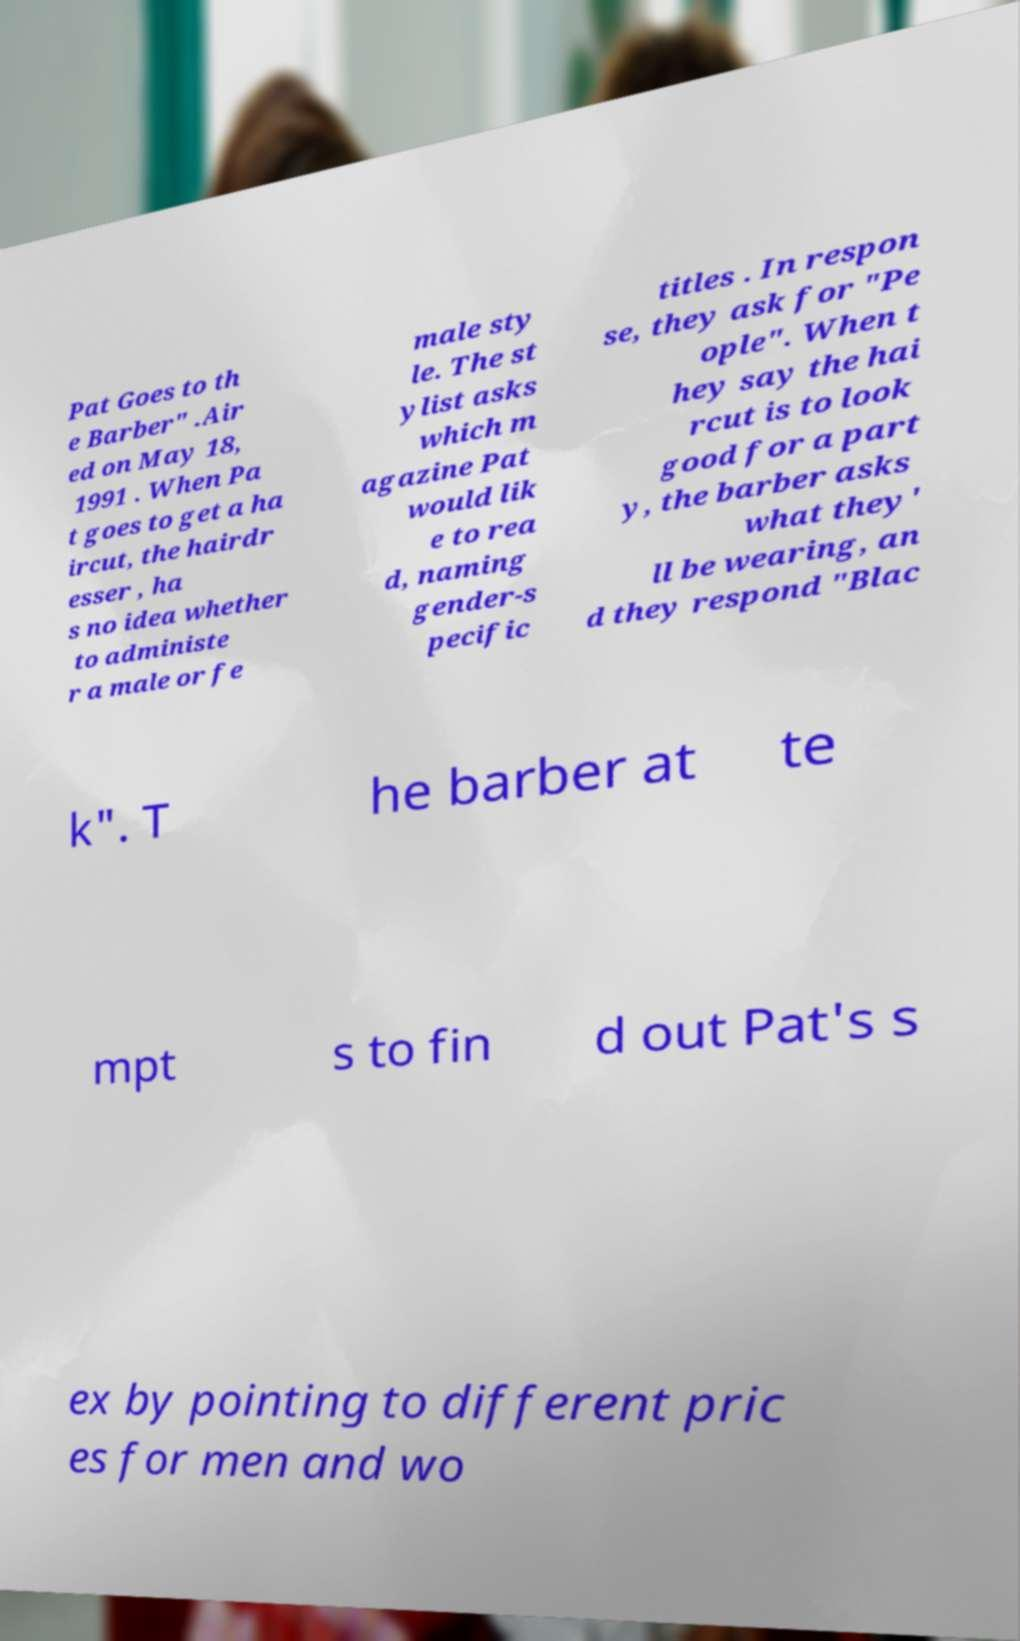Please identify and transcribe the text found in this image. Pat Goes to th e Barber" .Air ed on May 18, 1991 . When Pa t goes to get a ha ircut, the hairdr esser , ha s no idea whether to administe r a male or fe male sty le. The st ylist asks which m agazine Pat would lik e to rea d, naming gender-s pecific titles . In respon se, they ask for "Pe ople". When t hey say the hai rcut is to look good for a part y, the barber asks what they' ll be wearing, an d they respond "Blac k". T he barber at te mpt s to fin d out Pat's s ex by pointing to different pric es for men and wo 